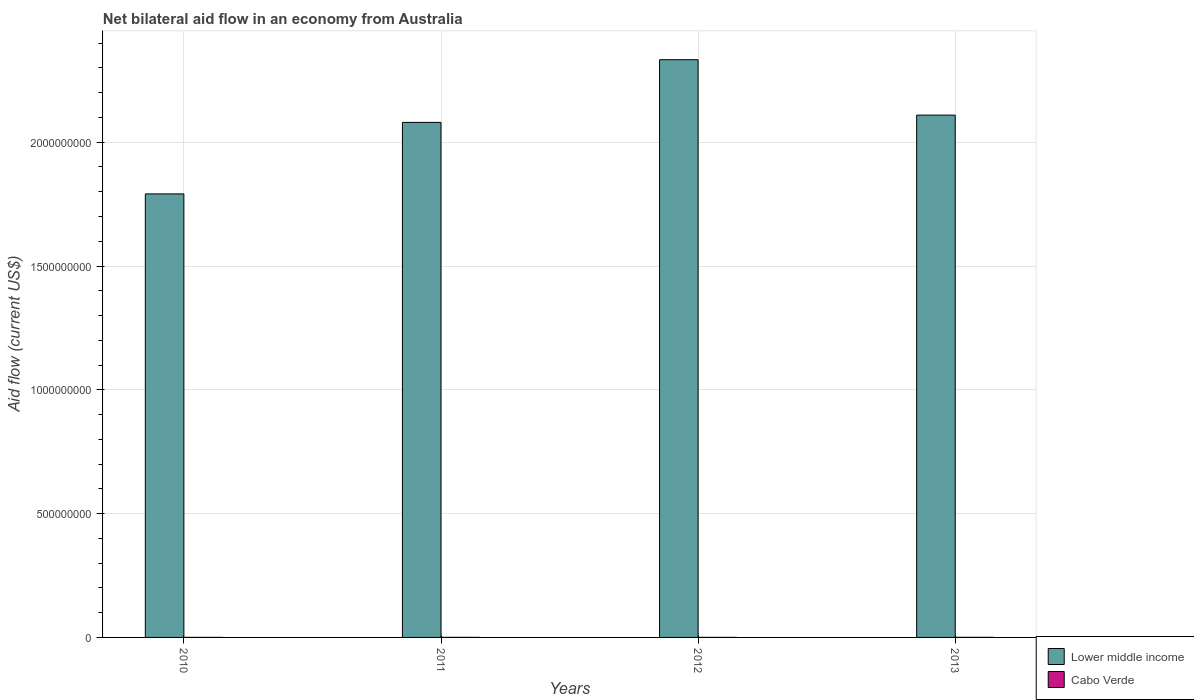How many different coloured bars are there?
Your answer should be very brief. 2. How many groups of bars are there?
Offer a very short reply. 4. Are the number of bars per tick equal to the number of legend labels?
Ensure brevity in your answer.  Yes. Are the number of bars on each tick of the X-axis equal?
Your response must be concise. Yes. What is the net bilateral aid flow in Lower middle income in 2010?
Offer a terse response. 1.79e+09. Across all years, what is the maximum net bilateral aid flow in Lower middle income?
Your answer should be compact. 2.33e+09. Across all years, what is the minimum net bilateral aid flow in Cabo Verde?
Your response must be concise. 1.60e+05. In which year was the net bilateral aid flow in Cabo Verde maximum?
Your answer should be very brief. 2013. What is the total net bilateral aid flow in Lower middle income in the graph?
Give a very brief answer. 8.31e+09. What is the difference between the net bilateral aid flow in Lower middle income in 2011 and that in 2013?
Give a very brief answer. -2.95e+07. What is the difference between the net bilateral aid flow in Lower middle income in 2010 and the net bilateral aid flow in Cabo Verde in 2013?
Give a very brief answer. 1.79e+09. What is the average net bilateral aid flow in Lower middle income per year?
Your response must be concise. 2.08e+09. In the year 2013, what is the difference between the net bilateral aid flow in Cabo Verde and net bilateral aid flow in Lower middle income?
Give a very brief answer. -2.11e+09. In how many years, is the net bilateral aid flow in Lower middle income greater than 800000000 US$?
Your response must be concise. 4. What is the ratio of the net bilateral aid flow in Lower middle income in 2010 to that in 2011?
Keep it short and to the point. 0.86. What is the difference between the highest and the second highest net bilateral aid flow in Lower middle income?
Provide a short and direct response. 2.24e+08. What is the difference between the highest and the lowest net bilateral aid flow in Cabo Verde?
Offer a very short reply. 2.50e+05. In how many years, is the net bilateral aid flow in Lower middle income greater than the average net bilateral aid flow in Lower middle income taken over all years?
Give a very brief answer. 3. What does the 2nd bar from the left in 2013 represents?
Give a very brief answer. Cabo Verde. What does the 2nd bar from the right in 2013 represents?
Offer a very short reply. Lower middle income. How many years are there in the graph?
Your response must be concise. 4. Are the values on the major ticks of Y-axis written in scientific E-notation?
Provide a short and direct response. No. Does the graph contain grids?
Make the answer very short. Yes. How many legend labels are there?
Your answer should be compact. 2. How are the legend labels stacked?
Offer a very short reply. Vertical. What is the title of the graph?
Offer a very short reply. Net bilateral aid flow in an economy from Australia. Does "French Polynesia" appear as one of the legend labels in the graph?
Your response must be concise. No. What is the label or title of the X-axis?
Offer a very short reply. Years. What is the Aid flow (current US$) in Lower middle income in 2010?
Provide a short and direct response. 1.79e+09. What is the Aid flow (current US$) in Cabo Verde in 2010?
Make the answer very short. 2.00e+05. What is the Aid flow (current US$) of Lower middle income in 2011?
Keep it short and to the point. 2.08e+09. What is the Aid flow (current US$) in Cabo Verde in 2011?
Your answer should be compact. 2.20e+05. What is the Aid flow (current US$) in Lower middle income in 2012?
Give a very brief answer. 2.33e+09. What is the Aid flow (current US$) in Lower middle income in 2013?
Give a very brief answer. 2.11e+09. What is the Aid flow (current US$) of Cabo Verde in 2013?
Give a very brief answer. 4.10e+05. Across all years, what is the maximum Aid flow (current US$) of Lower middle income?
Make the answer very short. 2.33e+09. Across all years, what is the minimum Aid flow (current US$) of Lower middle income?
Your response must be concise. 1.79e+09. Across all years, what is the minimum Aid flow (current US$) in Cabo Verde?
Offer a terse response. 1.60e+05. What is the total Aid flow (current US$) in Lower middle income in the graph?
Offer a very short reply. 8.31e+09. What is the total Aid flow (current US$) of Cabo Verde in the graph?
Keep it short and to the point. 9.90e+05. What is the difference between the Aid flow (current US$) in Lower middle income in 2010 and that in 2011?
Your response must be concise. -2.89e+08. What is the difference between the Aid flow (current US$) in Cabo Verde in 2010 and that in 2011?
Make the answer very short. -2.00e+04. What is the difference between the Aid flow (current US$) of Lower middle income in 2010 and that in 2012?
Ensure brevity in your answer.  -5.42e+08. What is the difference between the Aid flow (current US$) of Cabo Verde in 2010 and that in 2012?
Provide a succinct answer. 4.00e+04. What is the difference between the Aid flow (current US$) in Lower middle income in 2010 and that in 2013?
Provide a short and direct response. -3.18e+08. What is the difference between the Aid flow (current US$) of Cabo Verde in 2010 and that in 2013?
Keep it short and to the point. -2.10e+05. What is the difference between the Aid flow (current US$) in Lower middle income in 2011 and that in 2012?
Your response must be concise. -2.53e+08. What is the difference between the Aid flow (current US$) in Cabo Verde in 2011 and that in 2012?
Provide a succinct answer. 6.00e+04. What is the difference between the Aid flow (current US$) in Lower middle income in 2011 and that in 2013?
Give a very brief answer. -2.95e+07. What is the difference between the Aid flow (current US$) in Cabo Verde in 2011 and that in 2013?
Offer a very short reply. -1.90e+05. What is the difference between the Aid flow (current US$) of Lower middle income in 2012 and that in 2013?
Offer a very short reply. 2.24e+08. What is the difference between the Aid flow (current US$) of Lower middle income in 2010 and the Aid flow (current US$) of Cabo Verde in 2011?
Keep it short and to the point. 1.79e+09. What is the difference between the Aid flow (current US$) in Lower middle income in 2010 and the Aid flow (current US$) in Cabo Verde in 2012?
Ensure brevity in your answer.  1.79e+09. What is the difference between the Aid flow (current US$) of Lower middle income in 2010 and the Aid flow (current US$) of Cabo Verde in 2013?
Offer a terse response. 1.79e+09. What is the difference between the Aid flow (current US$) in Lower middle income in 2011 and the Aid flow (current US$) in Cabo Verde in 2012?
Give a very brief answer. 2.08e+09. What is the difference between the Aid flow (current US$) in Lower middle income in 2011 and the Aid flow (current US$) in Cabo Verde in 2013?
Offer a very short reply. 2.08e+09. What is the difference between the Aid flow (current US$) in Lower middle income in 2012 and the Aid flow (current US$) in Cabo Verde in 2013?
Provide a short and direct response. 2.33e+09. What is the average Aid flow (current US$) of Lower middle income per year?
Provide a short and direct response. 2.08e+09. What is the average Aid flow (current US$) of Cabo Verde per year?
Provide a succinct answer. 2.48e+05. In the year 2010, what is the difference between the Aid flow (current US$) of Lower middle income and Aid flow (current US$) of Cabo Verde?
Your response must be concise. 1.79e+09. In the year 2011, what is the difference between the Aid flow (current US$) of Lower middle income and Aid flow (current US$) of Cabo Verde?
Your answer should be very brief. 2.08e+09. In the year 2012, what is the difference between the Aid flow (current US$) in Lower middle income and Aid flow (current US$) in Cabo Verde?
Ensure brevity in your answer.  2.33e+09. In the year 2013, what is the difference between the Aid flow (current US$) of Lower middle income and Aid flow (current US$) of Cabo Verde?
Provide a short and direct response. 2.11e+09. What is the ratio of the Aid flow (current US$) of Lower middle income in 2010 to that in 2011?
Your answer should be very brief. 0.86. What is the ratio of the Aid flow (current US$) of Cabo Verde in 2010 to that in 2011?
Offer a very short reply. 0.91. What is the ratio of the Aid flow (current US$) in Lower middle income in 2010 to that in 2012?
Offer a terse response. 0.77. What is the ratio of the Aid flow (current US$) in Cabo Verde in 2010 to that in 2012?
Give a very brief answer. 1.25. What is the ratio of the Aid flow (current US$) of Lower middle income in 2010 to that in 2013?
Provide a succinct answer. 0.85. What is the ratio of the Aid flow (current US$) of Cabo Verde in 2010 to that in 2013?
Provide a succinct answer. 0.49. What is the ratio of the Aid flow (current US$) of Lower middle income in 2011 to that in 2012?
Provide a succinct answer. 0.89. What is the ratio of the Aid flow (current US$) of Cabo Verde in 2011 to that in 2012?
Offer a very short reply. 1.38. What is the ratio of the Aid flow (current US$) of Cabo Verde in 2011 to that in 2013?
Keep it short and to the point. 0.54. What is the ratio of the Aid flow (current US$) of Lower middle income in 2012 to that in 2013?
Ensure brevity in your answer.  1.11. What is the ratio of the Aid flow (current US$) of Cabo Verde in 2012 to that in 2013?
Provide a short and direct response. 0.39. What is the difference between the highest and the second highest Aid flow (current US$) of Lower middle income?
Make the answer very short. 2.24e+08. What is the difference between the highest and the second highest Aid flow (current US$) of Cabo Verde?
Make the answer very short. 1.90e+05. What is the difference between the highest and the lowest Aid flow (current US$) in Lower middle income?
Your answer should be compact. 5.42e+08. What is the difference between the highest and the lowest Aid flow (current US$) in Cabo Verde?
Offer a terse response. 2.50e+05. 